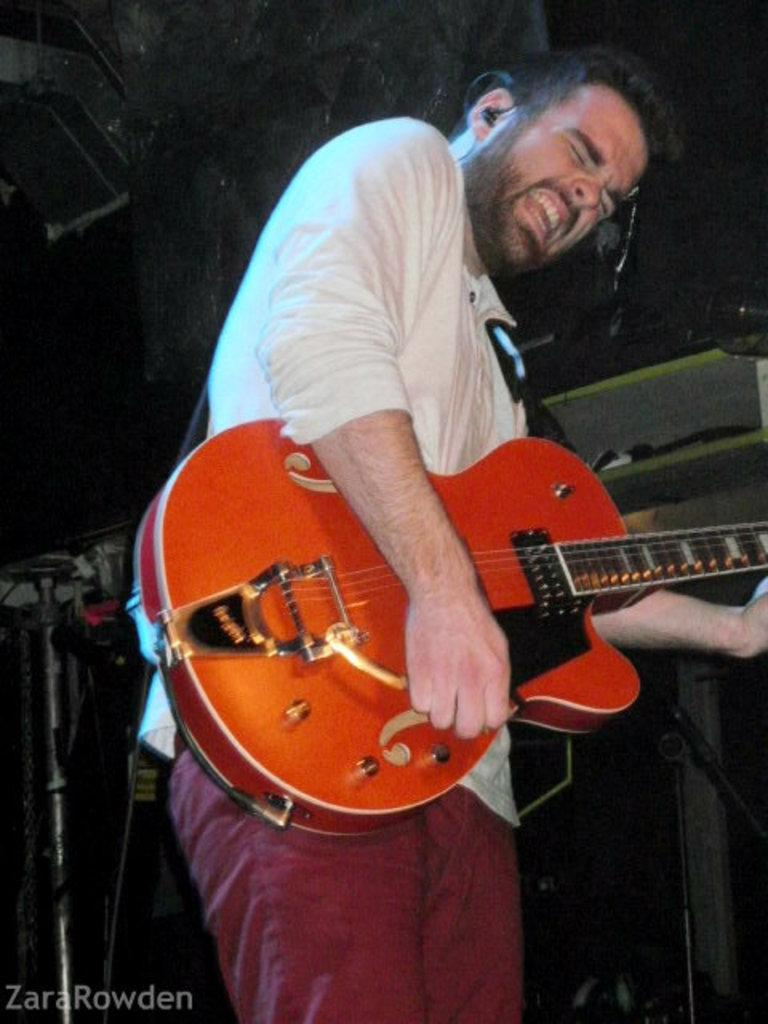Who is present in the image? There is a man in the image. What is the man doing in the image? The man is standing in the image. What object is the man holding in the image? The man is holding a guitar in the image. What type of tent can be seen in the background of the image? There is no tent present in the image. What is the man eating for breakfast in the image? There is no breakfast depicted in the image. 